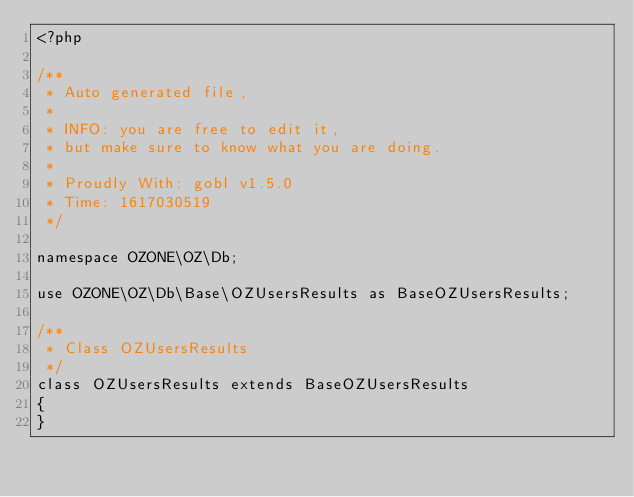<code> <loc_0><loc_0><loc_500><loc_500><_PHP_><?php

/**
 * Auto generated file,
 *
 * INFO: you are free to edit it,
 * but make sure to know what you are doing.
 *
 * Proudly With: gobl v1.5.0
 * Time: 1617030519
 */

namespace OZONE\OZ\Db;

use OZONE\OZ\Db\Base\OZUsersResults as BaseOZUsersResults;

/**
 * Class OZUsersResults
 */
class OZUsersResults extends BaseOZUsersResults
{
}
</code> 